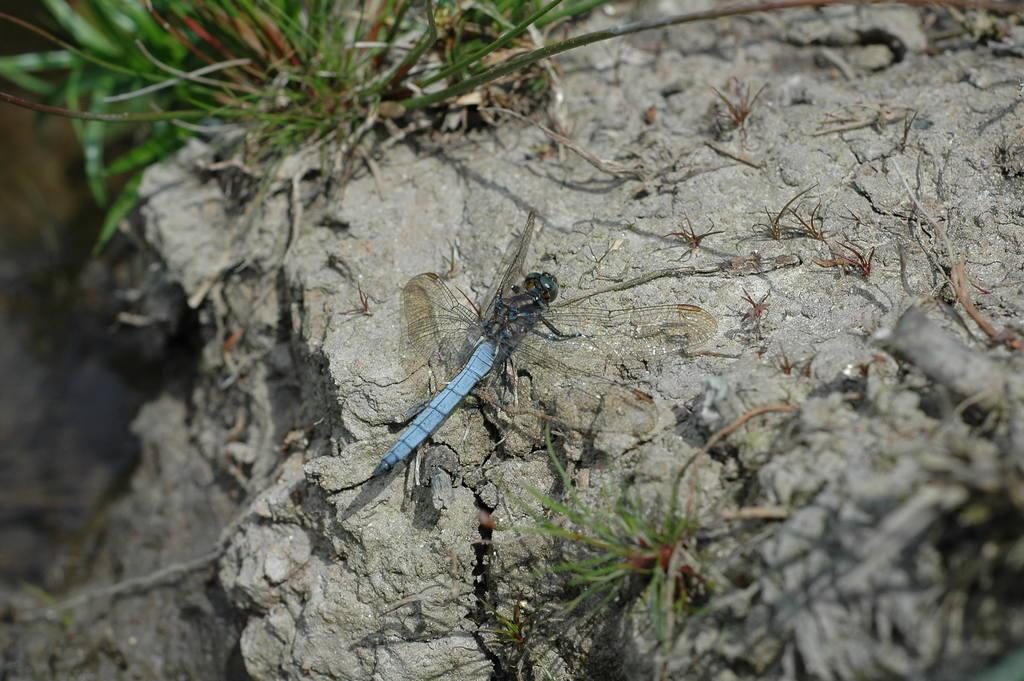What type of creature is present in the image? There is an insect in the image. Can you describe the coloration of the insect? The insect has blue, black, and green coloration. What type of vegetation is visible in the image? There is grass in the image. What color is the grass? The grass is green in color. How many sacks are being carried by the insect in the image? There are no sacks present in the image; it features an insect with blue, black, and green coloration and green grass. What type of cork is used to seal the insect's habitat in the image? There is no cork or insect habitat present in the image. 